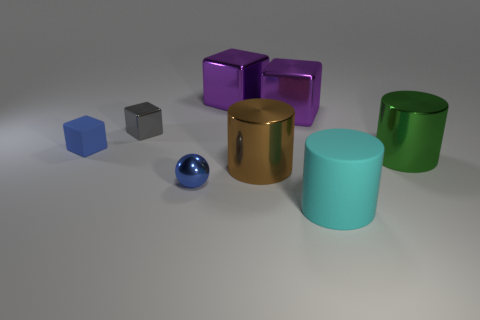Subtract all yellow cubes. Subtract all yellow cylinders. How many cubes are left? 4 Add 1 cyan things. How many objects exist? 9 Subtract all spheres. How many objects are left? 7 Add 5 small gray rubber objects. How many small gray rubber objects exist? 5 Subtract 1 gray blocks. How many objects are left? 7 Subtract all green cylinders. Subtract all gray metal cubes. How many objects are left? 6 Add 2 big cyan rubber cylinders. How many big cyan rubber cylinders are left? 3 